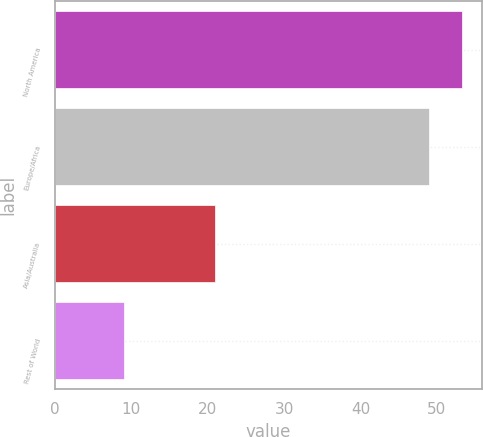Convert chart to OTSL. <chart><loc_0><loc_0><loc_500><loc_500><bar_chart><fcel>North America<fcel>Europe/Africa<fcel>Asia/Australia<fcel>Rest of World<nl><fcel>53.3<fcel>49<fcel>21<fcel>9<nl></chart> 